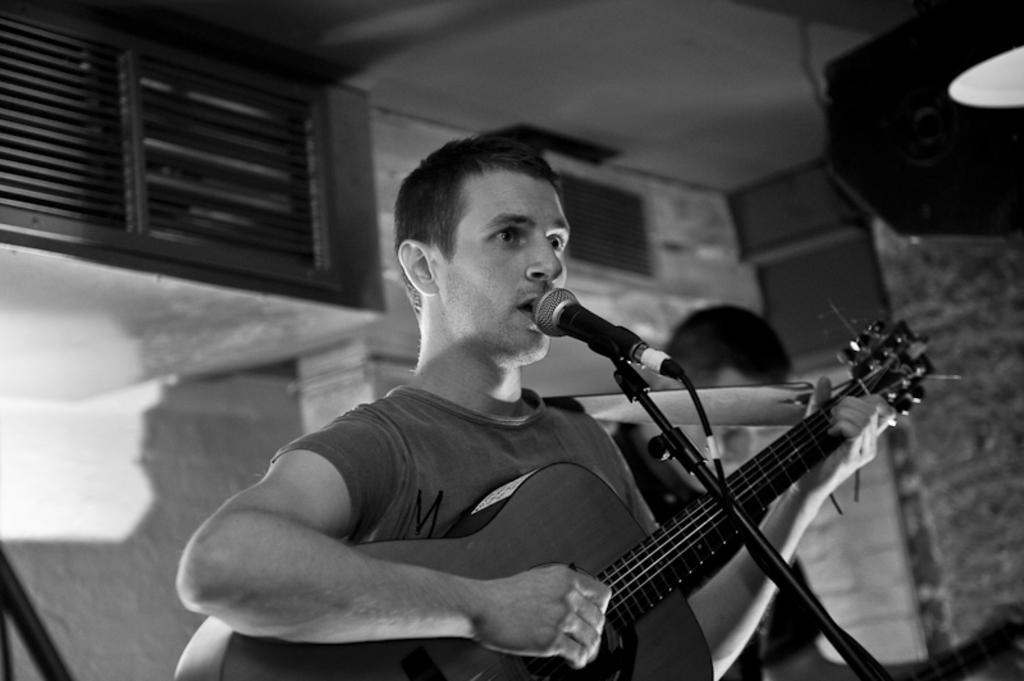Describe this image in one or two sentences. As we can see in the image there is a wall, window, two people over here. The man standing in the front is holding guitar and in front of him there is a mic. 